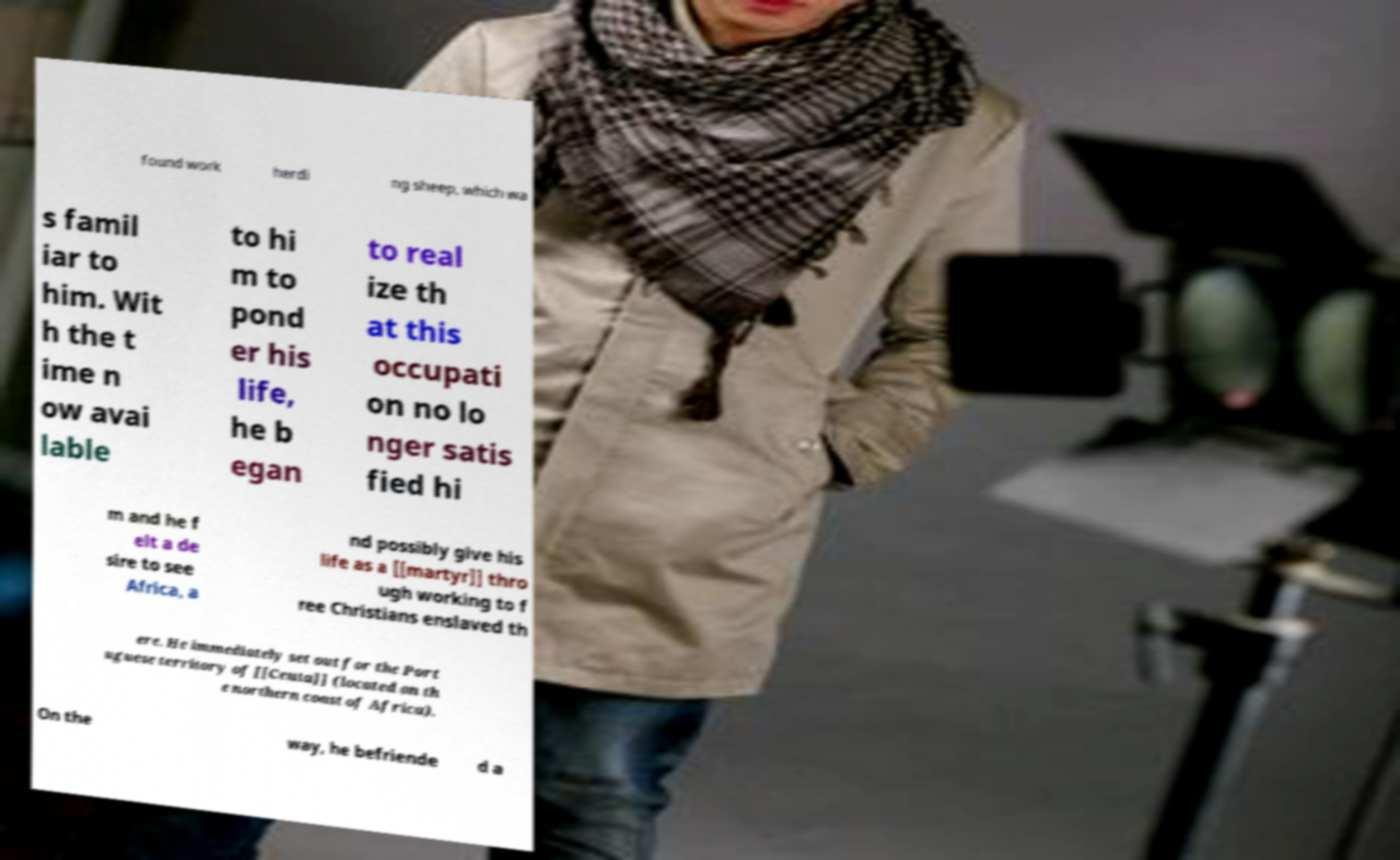There's text embedded in this image that I need extracted. Can you transcribe it verbatim? found work herdi ng sheep, which wa s famil iar to him. Wit h the t ime n ow avai lable to hi m to pond er his life, he b egan to real ize th at this occupati on no lo nger satis fied hi m and he f elt a de sire to see Africa, a nd possibly give his life as a [[martyr]] thro ugh working to f ree Christians enslaved th ere. He immediately set out for the Port uguese territory of [[Ceuta]] (located on th e northern coast of Africa). On the way, he befriende d a 